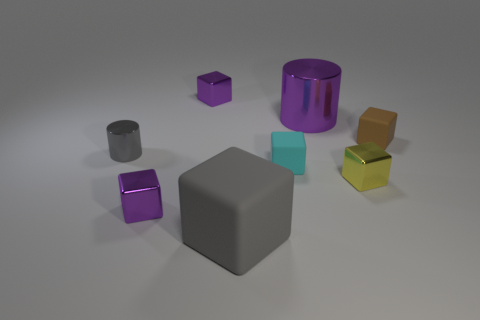There is a purple metallic cube that is behind the small matte object left of the big cylinder; is there a small shiny object on the right side of it?
Your answer should be compact. Yes. Is the cyan object made of the same material as the brown cube?
Provide a short and direct response. Yes. What material is the small purple cube behind the tiny rubber block in front of the brown object made of?
Keep it short and to the point. Metal. How big is the rubber thing right of the tiny cyan thing?
Keep it short and to the point. Small. What color is the small shiny object that is both in front of the tiny gray metal object and left of the large purple object?
Offer a very short reply. Purple. Is the size of the metallic cylinder that is on the left side of the gray matte block the same as the brown thing?
Offer a terse response. Yes. There is a cylinder that is on the right side of the gray cube; are there any large objects to the left of it?
Provide a short and direct response. Yes. What is the small gray cylinder made of?
Make the answer very short. Metal. Are there any big gray blocks to the left of the small cyan matte object?
Your response must be concise. Yes. There is a cyan rubber thing that is the same shape as the brown matte thing; what is its size?
Offer a very short reply. Small. 